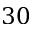<formula> <loc_0><loc_0><loc_500><loc_500>3 0</formula> 